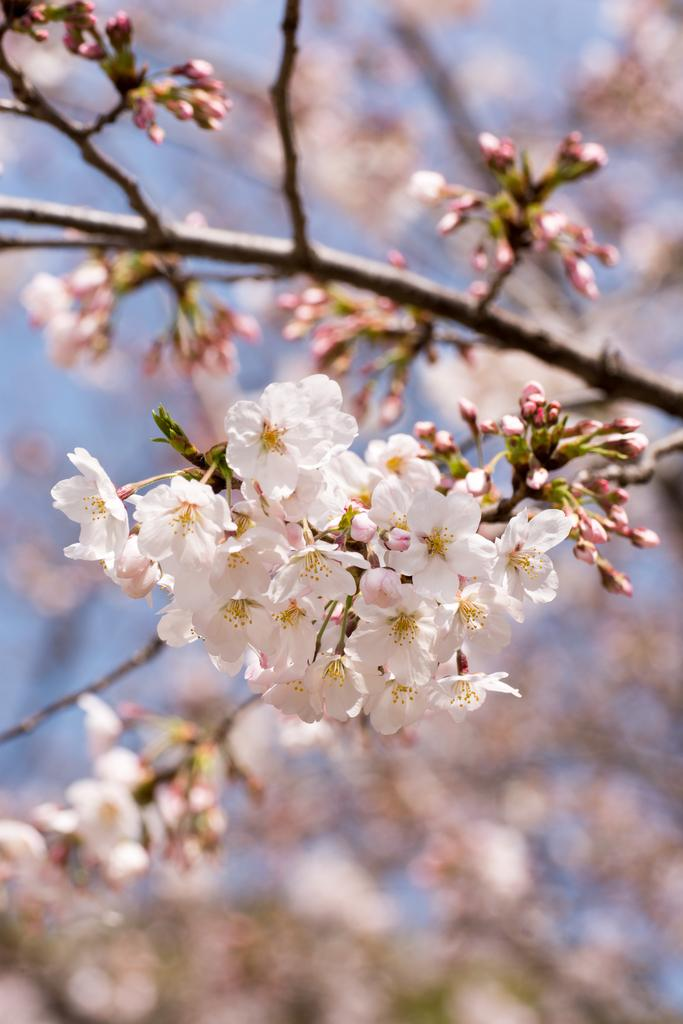What can be seen in the foreground of the picture? There are flowers, buds, and stems in the foreground of the picture. Can you describe the tree in the background of the picture? There is a tree in the background of the picture, although it is blurred. What type of crime is being committed in the picture? There is no crime present in the picture; it features flowers, buds, stems, and a blurred tree in the background. How much noise can be heard coming from the flowers in the picture? Flowers do not produce noise, so it is not possible to determine the noise level in the picture based on the flowers. 